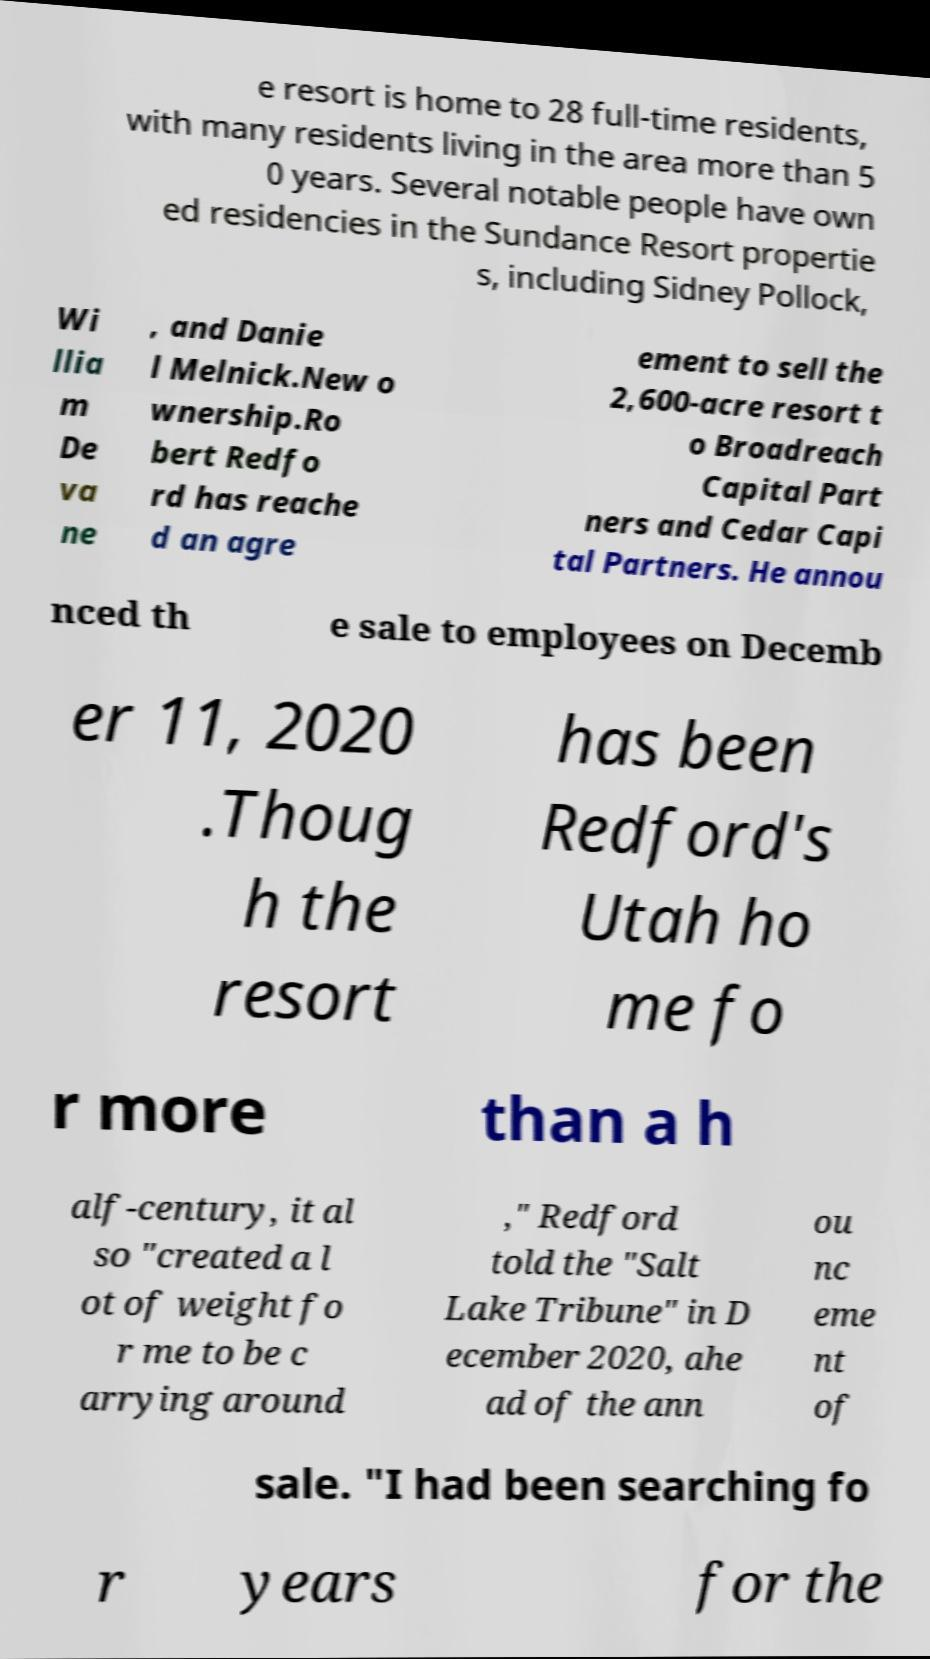Could you assist in decoding the text presented in this image and type it out clearly? e resort is home to 28 full-time residents, with many residents living in the area more than 5 0 years. Several notable people have own ed residencies in the Sundance Resort propertie s, including Sidney Pollock, Wi llia m De va ne , and Danie l Melnick.New o wnership.Ro bert Redfo rd has reache d an agre ement to sell the 2,600-acre resort t o Broadreach Capital Part ners and Cedar Capi tal Partners. He annou nced th e sale to employees on Decemb er 11, 2020 .Thoug h the resort has been Redford's Utah ho me fo r more than a h alf-century, it al so "created a l ot of weight fo r me to be c arrying around ," Redford told the "Salt Lake Tribune" in D ecember 2020, ahe ad of the ann ou nc eme nt of sale. "I had been searching fo r years for the 